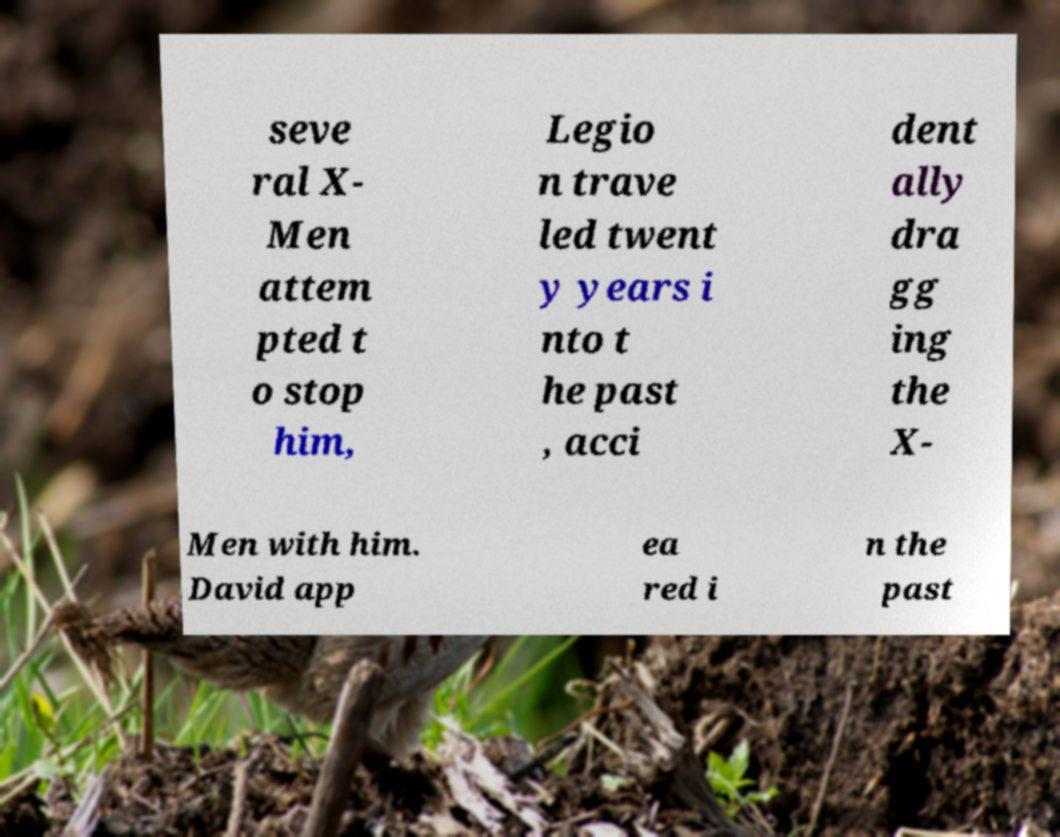There's text embedded in this image that I need extracted. Can you transcribe it verbatim? seve ral X- Men attem pted t o stop him, Legio n trave led twent y years i nto t he past , acci dent ally dra gg ing the X- Men with him. David app ea red i n the past 